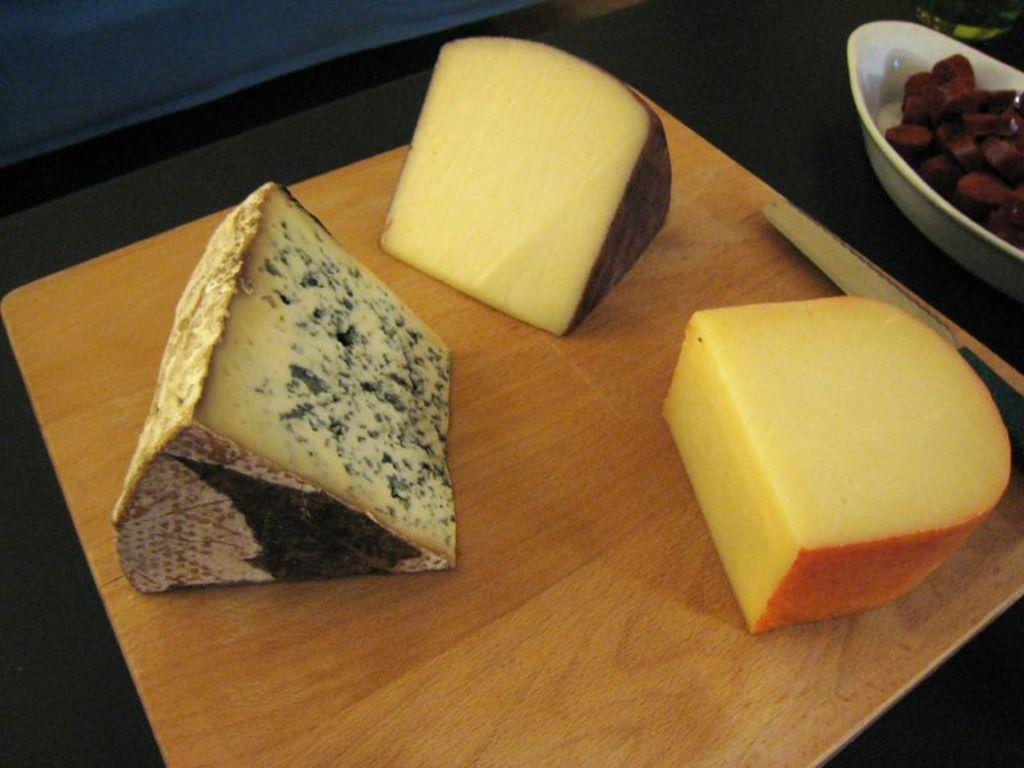What type of food can be seen in the image? There are pieces of cheese in the image. What utensil is present in the image? There is a knife in the image. What else is on the table besides the cheese and knife? There is a bowl of chopped vegetables in the image. Where are the objects placed in the image? The objects are placed on a table. Can you see a deer walking through the kitchen in the image? No, there is no deer or kitchen present in the image. 